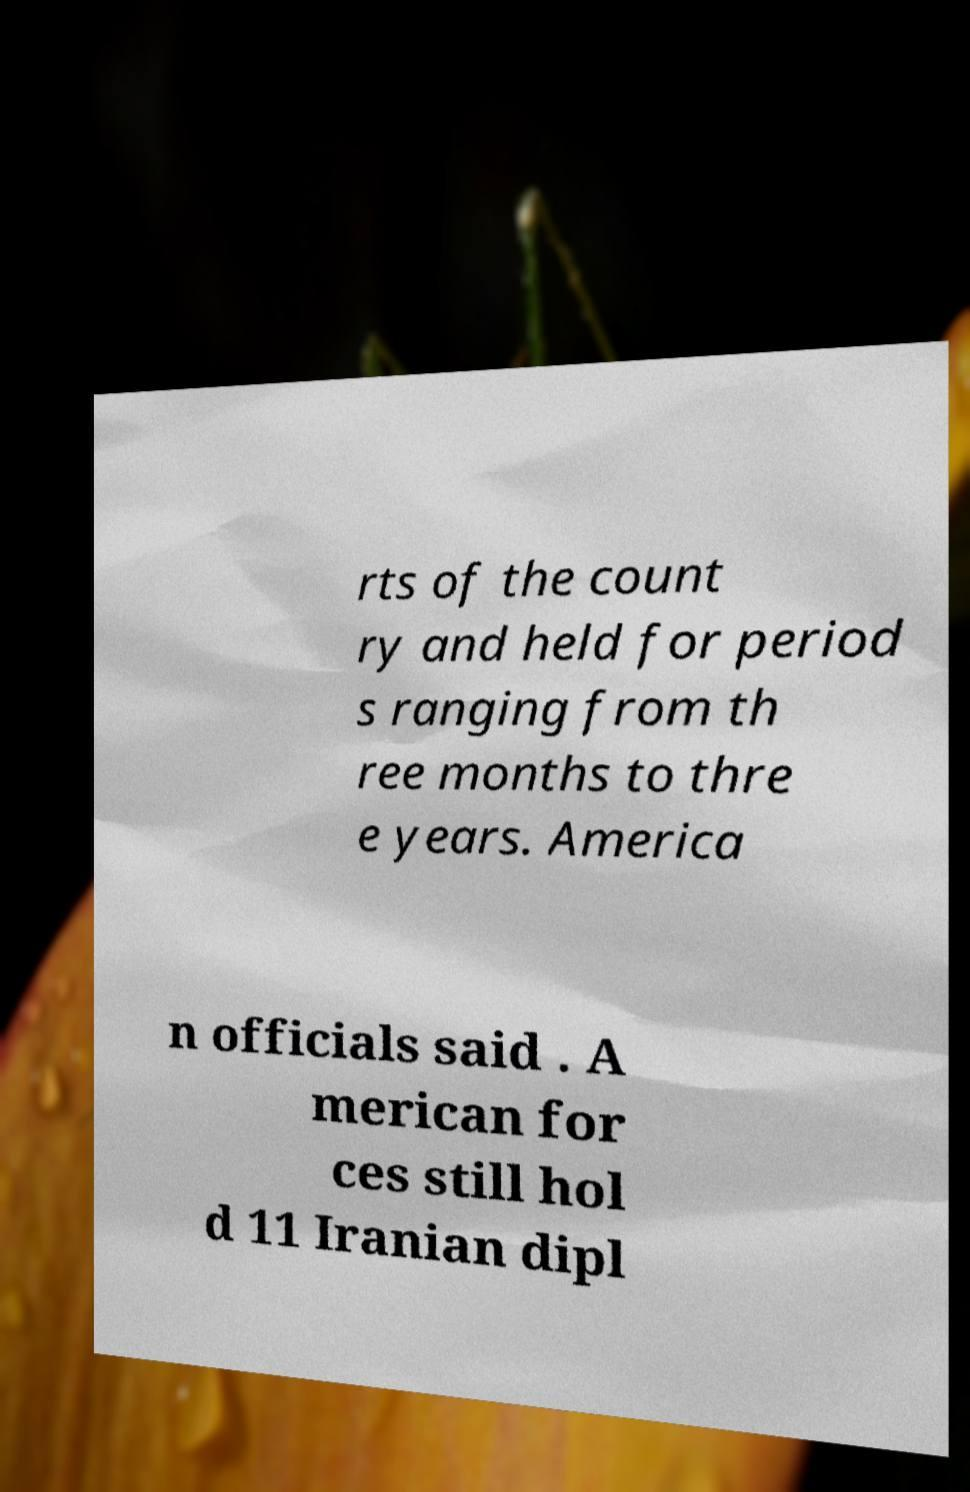There's text embedded in this image that I need extracted. Can you transcribe it verbatim? rts of the count ry and held for period s ranging from th ree months to thre e years. America n officials said . A merican for ces still hol d 11 Iranian dipl 